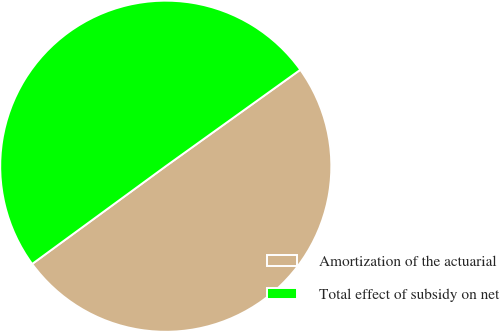Convert chart. <chart><loc_0><loc_0><loc_500><loc_500><pie_chart><fcel>Amortization of the actuarial<fcel>Total effect of subsidy on net<nl><fcel>49.85%<fcel>50.15%<nl></chart> 